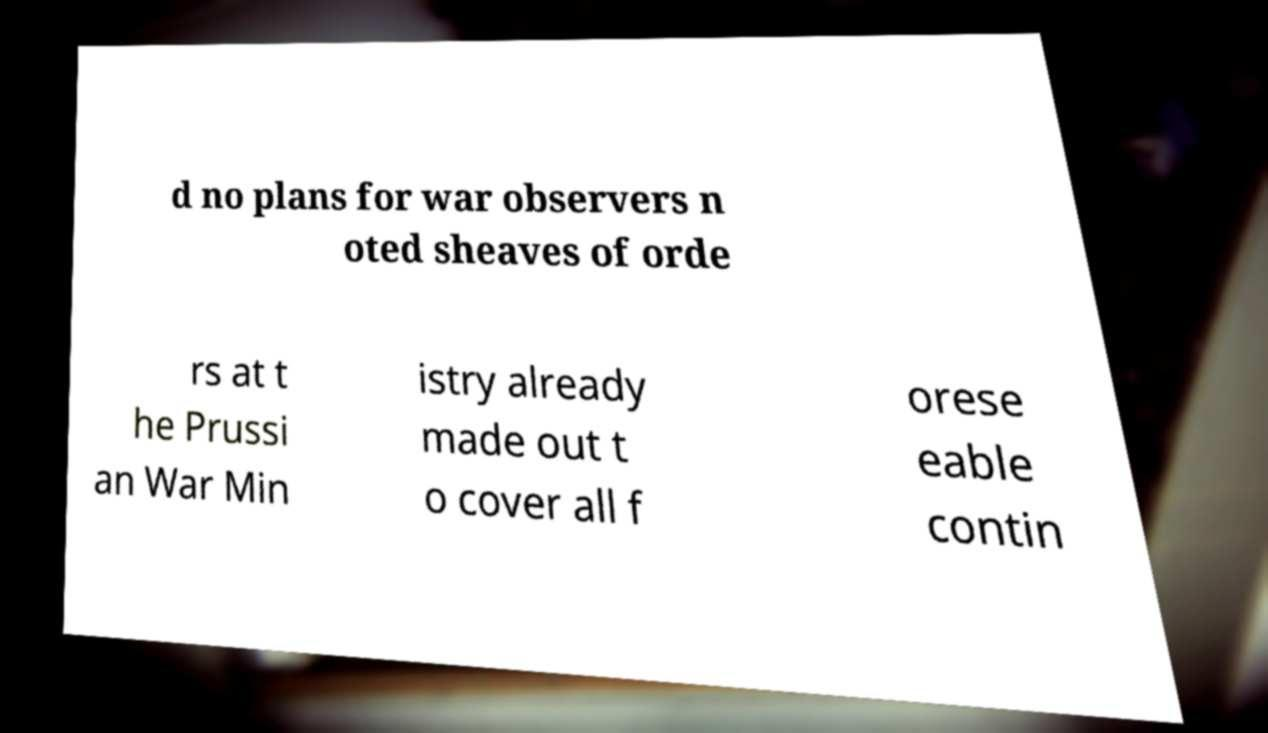Can you accurately transcribe the text from the provided image for me? d no plans for war observers n oted sheaves of orde rs at t he Prussi an War Min istry already made out t o cover all f orese eable contin 